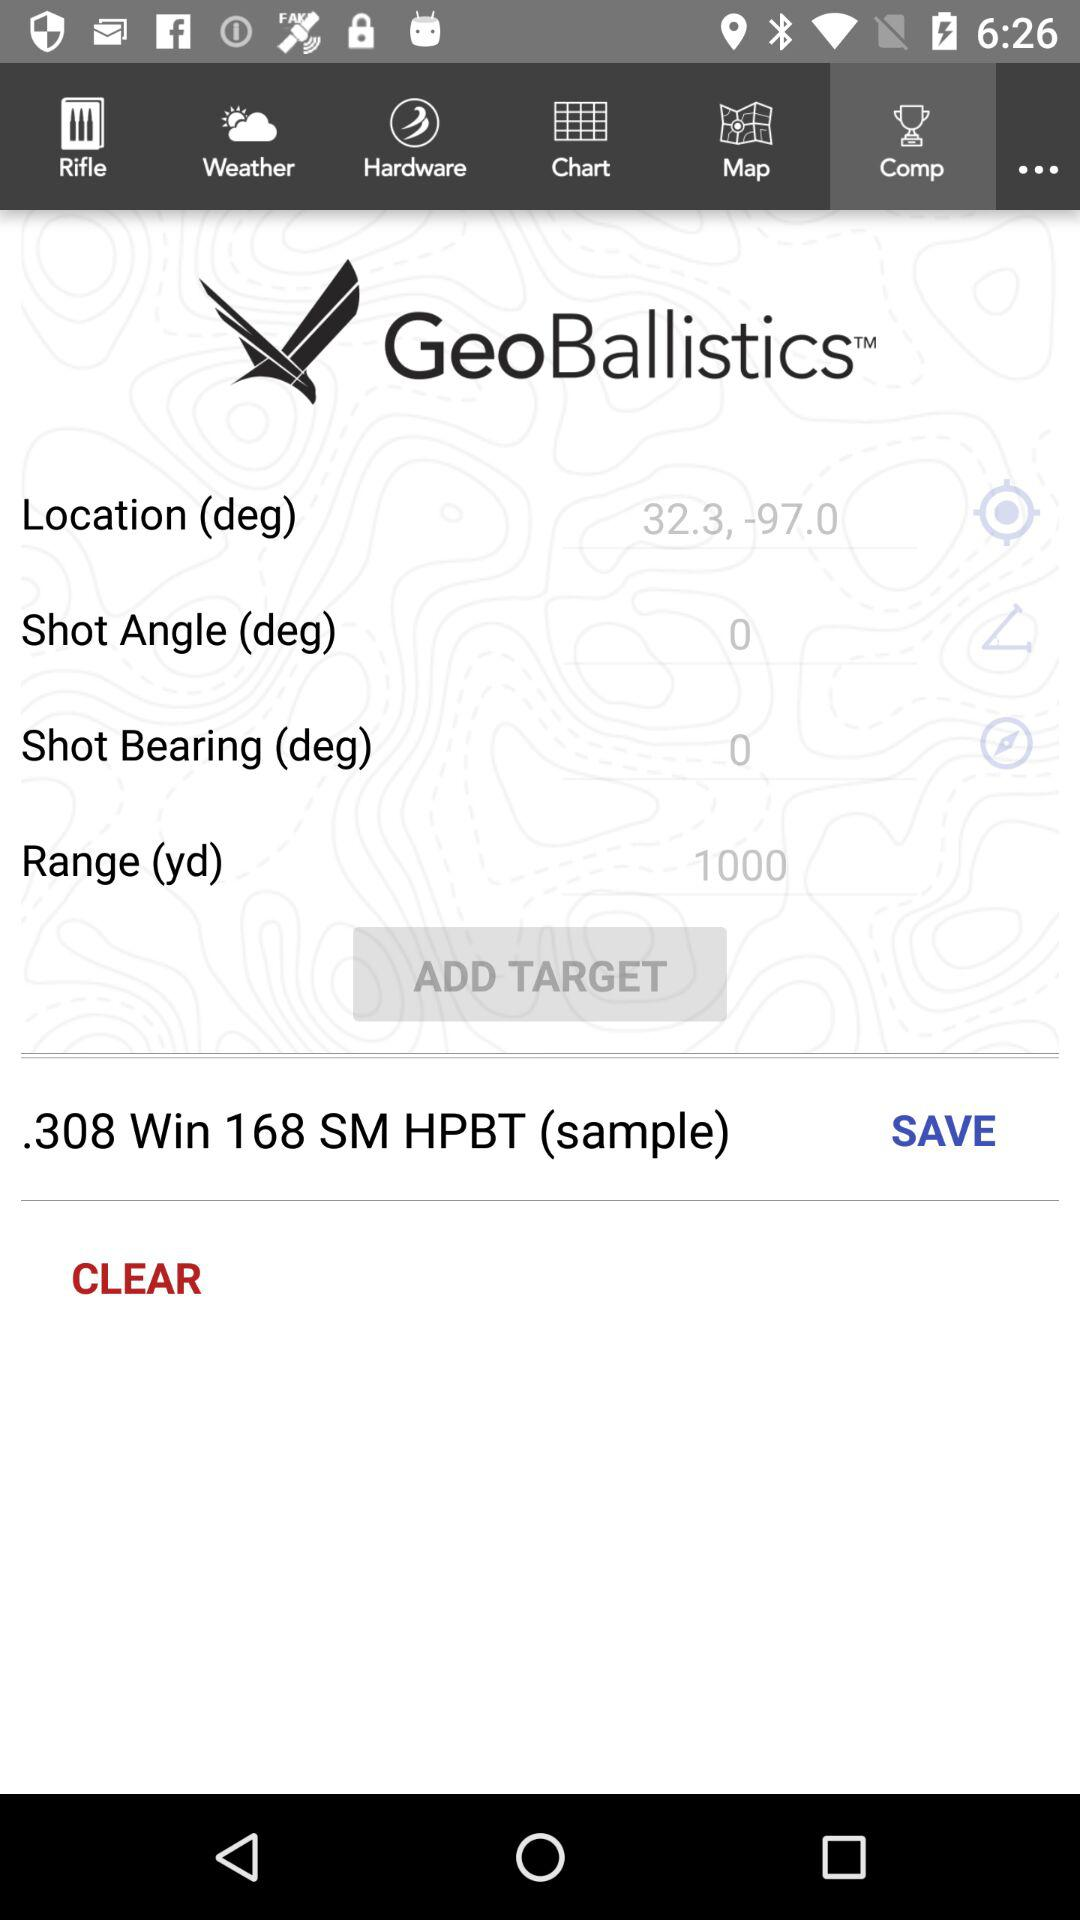What is the range(yd) of geoballistics? The range of geoballistics is 1000 yd. 